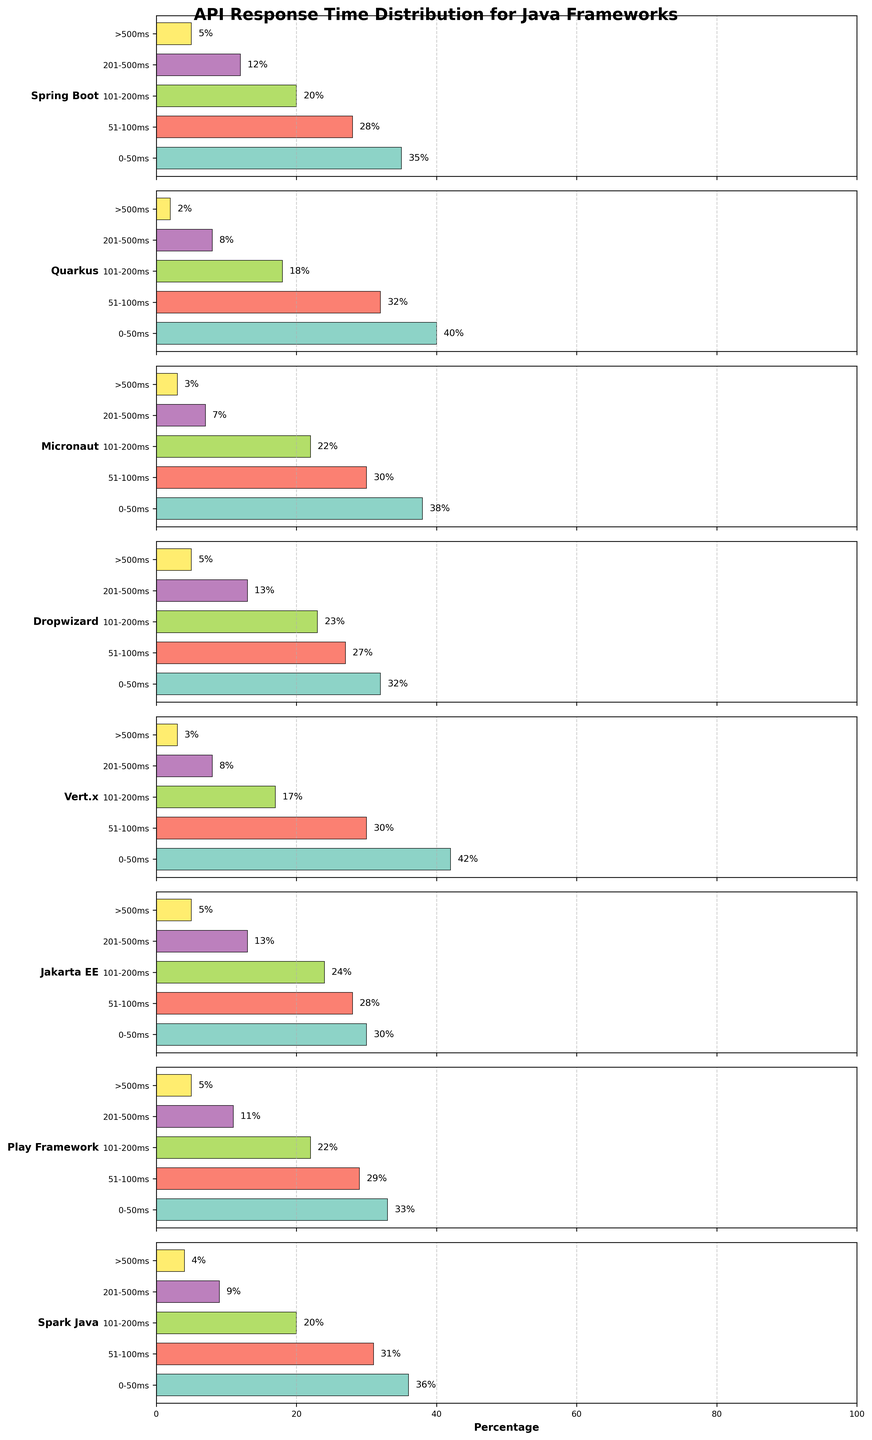What is the title of the figure? The title is displayed at the top of the figure, and it summarizes what the figure is about.
Answer: API Response Time Distribution for Java Frameworks Which framework has the highest percentage of responses in the 0-50ms category? We need to look at the 0-50ms category across all frameworks and identify the one with the highest value. Vert.x has the highest bar in this category.
Answer: Vert.x How many frameworks have more than 20% of responses in the 201-500ms category? To find the answer, check the bars in the 201-500ms category for each framework and count those above 20%. Only Dropwizard and Jakarta EE have more than 20% in this category.
Answer: 2 Which framework has the lowest percentage of responses greater than 500ms? We need to check the '>500ms' category for each framework and identify the lowest one. Quarkus has the lowest value here.
Answer: Quarkus What is the combined percentage of responses less than or equal to 100ms for the Play Framework? Sum the percentages of the 0-50ms and 51-100ms categories for the Play Framework. This is 33% + 29%.
Answer: 62% How does the percentage of responses in the 101-200ms category for Micronaut compare to Spring Boot? Compare the values in the 101-200ms category for both frameworks. Micronaut has 22%, while Spring Boot has 20%. Micronaut's percentage is higher.
Answer: Micronaut is higher Which framework has the most balanced distribution of response times across all categories? To find the framework with the most balanced distribution, compare the bars across all categories and see which has the least variation in values. Jakarta EE values are quite evenly distributed.
Answer: Jakarta EE What is the difference in the percentage of responses in the 51-100ms category between Spark Java and Quarkus? Subtract the percentage for Quarkus in the 51-100ms category from the percentage for Spark Java in the same category. This is 31% - 32%.
Answer: -1% How many frameworks have a percentage of responses in the >500ms category that is exactly 5%? Check the '>500ms' category for all frameworks and count those that have exactly 5%. These are Spring Boot, Dropwizard, Jakarta EE, and Play Framework.
Answer: 4 